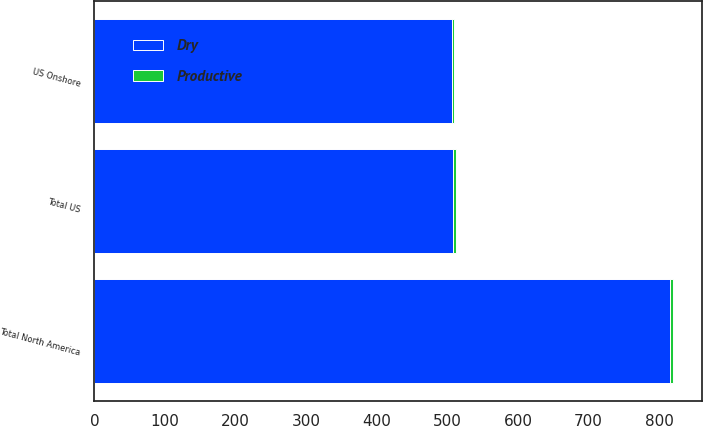<chart> <loc_0><loc_0><loc_500><loc_500><stacked_bar_chart><ecel><fcel>US Onshore<fcel>Total US<fcel>Total North America<nl><fcel>Dry<fcel>506.5<fcel>508<fcel>815.2<nl><fcel>Productive<fcel>3<fcel>3.8<fcel>3.8<nl></chart> 